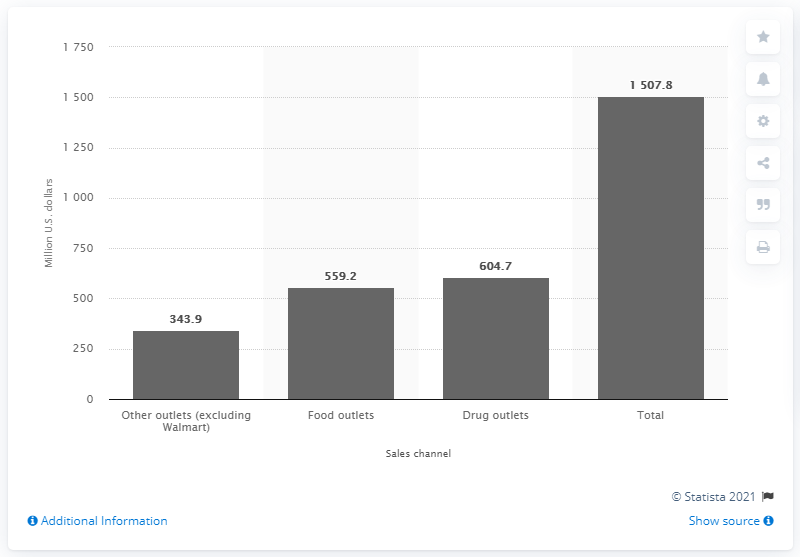List a handful of essential elements in this visual. In 2010 and 2011, the total sales of batteries in the United States were 1507.8 units. In the 2010/2011 fiscal year, a total of 604.7 million U.S. dollars were sold through drug outlets. 